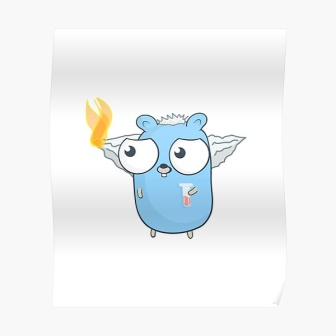Envision a practical scenario where the creature interacts with an adventurer. Adventurer: *stumbling into the clearing* Whoa, what are you?
Creature: *blinks its wide eyes* I am a guardian of Whispering Woods. You seem lost. Can I assist you?
Adventurer: I was seeking the legendary Healing Waters. My village is in need...
Creature: Follow me. The path is tricky, but I can guide you. Take care to avoid the Thorny Vines; they don’t take kindly to strangers. 